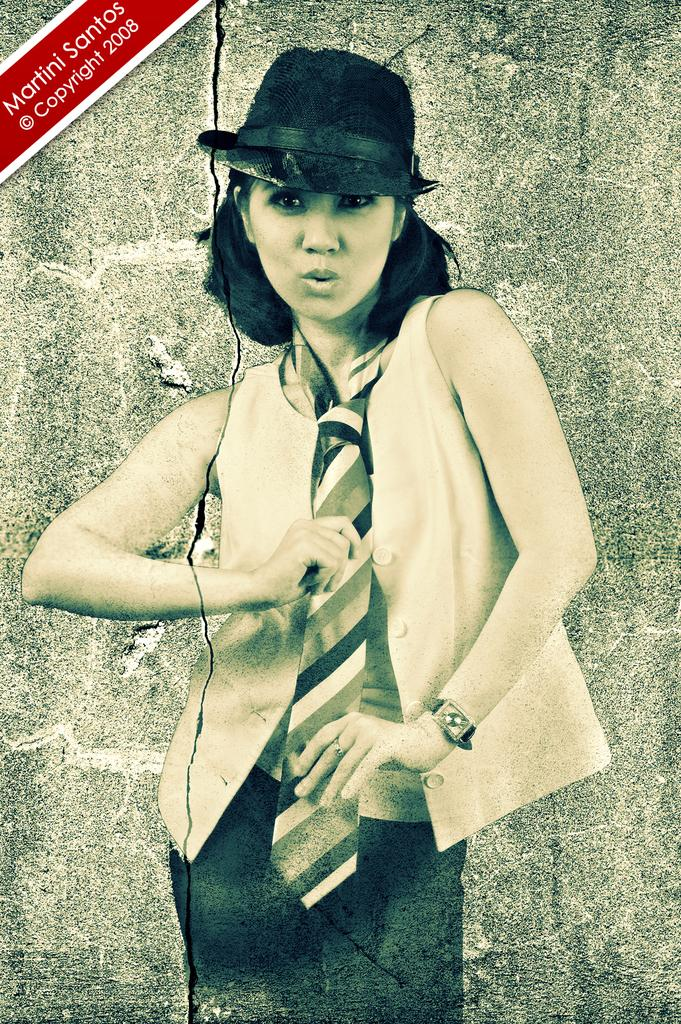Who is the main subject in the image? There is a woman in the front of the image. What can be seen in the background of the image? There is a wall in the background of the image. Where is the text located in the image? The text is at the left top of the image. What type of scissors can be seen cutting through the woman's hair in the image? There are no scissors or hair cutting activity depicted in the image. 